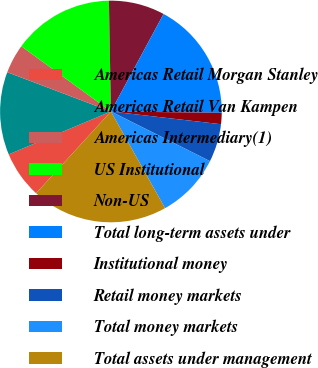<chart> <loc_0><loc_0><loc_500><loc_500><pie_chart><fcel>Americas Retail Morgan Stanley<fcel>Americas Retail Van Kampen<fcel>Americas Intermediary(1)<fcel>US Institutional<fcel>Non-US<fcel>Total long-term assets under<fcel>Institutional money<fcel>Retail money markets<fcel>Total money markets<fcel>Total assets under management<nl><fcel>6.87%<fcel>12.09%<fcel>4.25%<fcel>14.7%<fcel>8.17%<fcel>17.31%<fcel>1.64%<fcel>5.56%<fcel>9.48%<fcel>19.92%<nl></chart> 